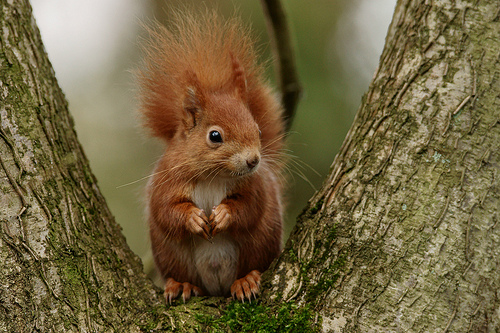<image>
Is there a squirrel on the tree? Yes. Looking at the image, I can see the squirrel is positioned on top of the tree, with the tree providing support. Is there a squirrel to the left of the tree? No. The squirrel is not to the left of the tree. From this viewpoint, they have a different horizontal relationship. Where is the squirrel in relation to the branch? Is it under the branch? No. The squirrel is not positioned under the branch. The vertical relationship between these objects is different. Is there a squirrel in the tree? Yes. The squirrel is contained within or inside the tree, showing a containment relationship. 